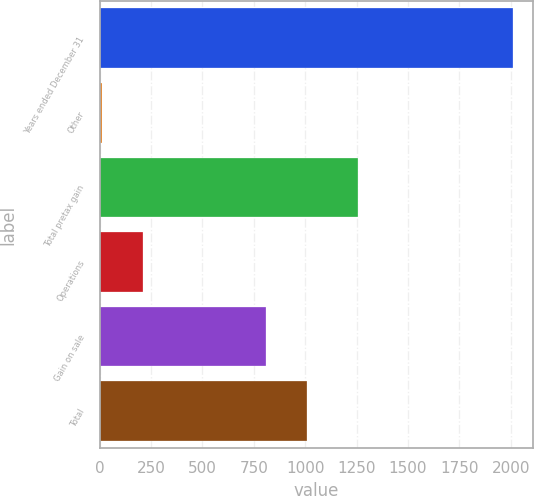Convert chart. <chart><loc_0><loc_0><loc_500><loc_500><bar_chart><fcel>Years ended December 31<fcel>Other<fcel>Total pretax gain<fcel>Operations<fcel>Gain on sale<fcel>Total<nl><fcel>2008<fcel>12<fcel>1256<fcel>211.6<fcel>811<fcel>1010.6<nl></chart> 